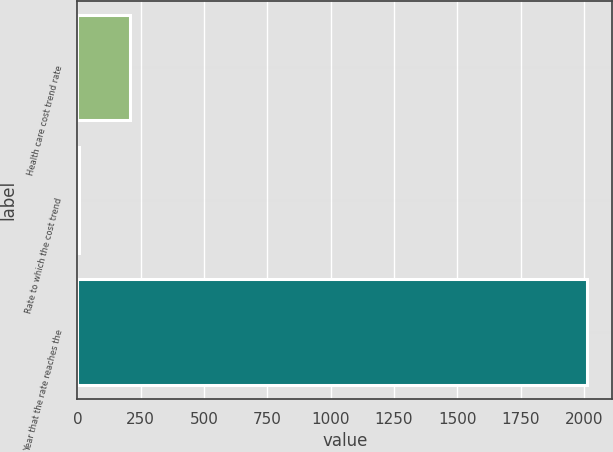Convert chart. <chart><loc_0><loc_0><loc_500><loc_500><bar_chart><fcel>Health care cost trend rate<fcel>Rate to which the cost trend<fcel>Year that the rate reaches the<nl><fcel>205.7<fcel>5<fcel>2012<nl></chart> 